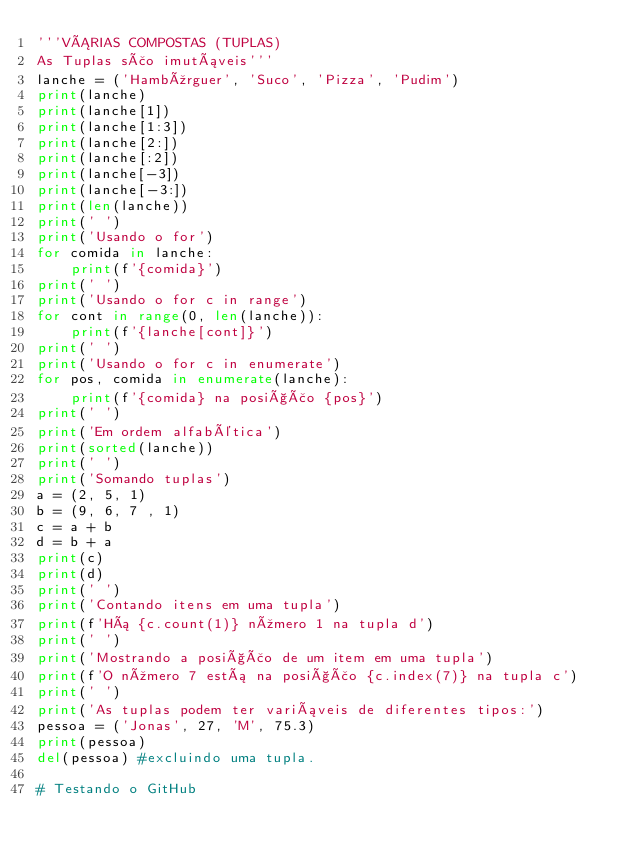<code> <loc_0><loc_0><loc_500><loc_500><_Python_>'''VÁRIAS COMPOSTAS (TUPLAS)
As Tuplas são imutáveis'''
lanche = ('Hambúrguer', 'Suco', 'Pizza', 'Pudim')
print(lanche)
print(lanche[1])
print(lanche[1:3])
print(lanche[2:])
print(lanche[:2])
print(lanche[-3])
print(lanche[-3:])
print(len(lanche))
print(' ')
print('Usando o for')
for comida in lanche:
    print(f'{comida}')
print(' ')
print('Usando o for c in range')
for cont in range(0, len(lanche)):
    print(f'{lanche[cont]}')
print(' ')
print('Usando o for c in enumerate')
for pos, comida in enumerate(lanche):
    print(f'{comida} na posição {pos}')
print(' ')
print('Em ordem alfabética')
print(sorted(lanche))
print(' ')
print('Somando tuplas')
a = (2, 5, 1)
b = (9, 6, 7 , 1)
c = a + b
d = b + a
print(c)
print(d)
print(' ')
print('Contando itens em uma tupla')
print(f'Há {c.count(1)} número 1 na tupla d')
print(' ')
print('Mostrando a posição de um item em uma tupla')
print(f'O número 7 está na posição {c.index(7)} na tupla c')
print(' ')
print('As tuplas podem ter variáveis de diferentes tipos:')
pessoa = ('Jonas', 27, 'M', 75.3)
print(pessoa)
del(pessoa) #excluindo uma tupla.

# Testando o GitHub
</code> 